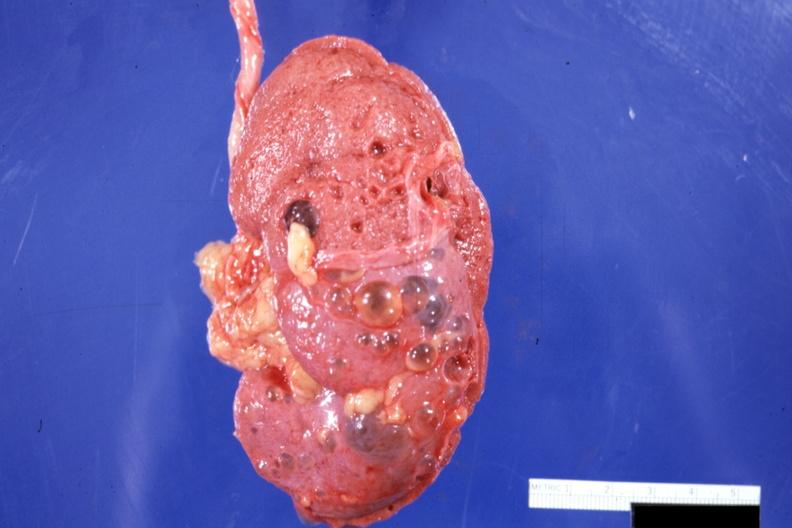what is present?
Answer the question using a single word or phrase. Kidney 